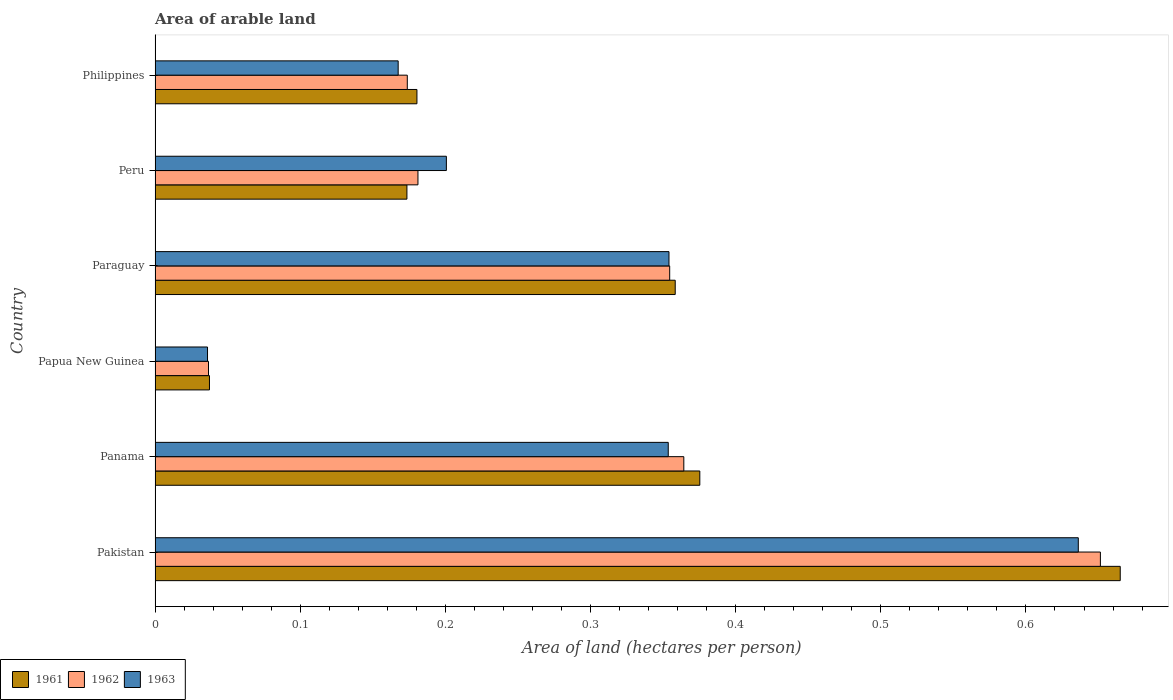How many different coloured bars are there?
Provide a succinct answer. 3. Are the number of bars per tick equal to the number of legend labels?
Your answer should be compact. Yes. Are the number of bars on each tick of the Y-axis equal?
Keep it short and to the point. Yes. How many bars are there on the 4th tick from the top?
Your answer should be compact. 3. What is the label of the 3rd group of bars from the top?
Offer a terse response. Paraguay. In how many cases, is the number of bars for a given country not equal to the number of legend labels?
Give a very brief answer. 0. What is the total arable land in 1962 in Papua New Guinea?
Offer a terse response. 0.04. Across all countries, what is the maximum total arable land in 1961?
Make the answer very short. 0.66. Across all countries, what is the minimum total arable land in 1963?
Offer a very short reply. 0.04. In which country was the total arable land in 1961 minimum?
Your answer should be very brief. Papua New Guinea. What is the total total arable land in 1962 in the graph?
Give a very brief answer. 1.76. What is the difference between the total arable land in 1962 in Peru and that in Philippines?
Provide a short and direct response. 0.01. What is the difference between the total arable land in 1961 in Pakistan and the total arable land in 1963 in Papua New Guinea?
Keep it short and to the point. 0.63. What is the average total arable land in 1962 per country?
Offer a very short reply. 0.29. What is the difference between the total arable land in 1961 and total arable land in 1963 in Pakistan?
Your response must be concise. 0.03. In how many countries, is the total arable land in 1962 greater than 0.52 hectares per person?
Give a very brief answer. 1. What is the ratio of the total arable land in 1961 in Paraguay to that in Philippines?
Give a very brief answer. 1.99. Is the difference between the total arable land in 1961 in Panama and Papua New Guinea greater than the difference between the total arable land in 1963 in Panama and Papua New Guinea?
Your answer should be compact. Yes. What is the difference between the highest and the second highest total arable land in 1961?
Your answer should be very brief. 0.29. What is the difference between the highest and the lowest total arable land in 1962?
Offer a very short reply. 0.61. In how many countries, is the total arable land in 1963 greater than the average total arable land in 1963 taken over all countries?
Provide a short and direct response. 3. Is the sum of the total arable land in 1963 in Peru and Philippines greater than the maximum total arable land in 1962 across all countries?
Provide a succinct answer. No. What does the 1st bar from the top in Philippines represents?
Ensure brevity in your answer.  1963. How many bars are there?
Offer a terse response. 18. Are all the bars in the graph horizontal?
Offer a very short reply. Yes. How many countries are there in the graph?
Provide a succinct answer. 6. What is the difference between two consecutive major ticks on the X-axis?
Give a very brief answer. 0.1. Does the graph contain grids?
Give a very brief answer. No. Where does the legend appear in the graph?
Provide a succinct answer. Bottom left. What is the title of the graph?
Offer a very short reply. Area of arable land. What is the label or title of the X-axis?
Keep it short and to the point. Area of land (hectares per person). What is the label or title of the Y-axis?
Provide a short and direct response. Country. What is the Area of land (hectares per person) of 1961 in Pakistan?
Provide a succinct answer. 0.66. What is the Area of land (hectares per person) in 1962 in Pakistan?
Provide a short and direct response. 0.65. What is the Area of land (hectares per person) of 1963 in Pakistan?
Your answer should be very brief. 0.64. What is the Area of land (hectares per person) in 1961 in Panama?
Offer a very short reply. 0.38. What is the Area of land (hectares per person) of 1962 in Panama?
Your response must be concise. 0.36. What is the Area of land (hectares per person) in 1963 in Panama?
Your answer should be compact. 0.35. What is the Area of land (hectares per person) of 1961 in Papua New Guinea?
Make the answer very short. 0.04. What is the Area of land (hectares per person) in 1962 in Papua New Guinea?
Your answer should be very brief. 0.04. What is the Area of land (hectares per person) in 1963 in Papua New Guinea?
Provide a succinct answer. 0.04. What is the Area of land (hectares per person) of 1961 in Paraguay?
Your answer should be very brief. 0.36. What is the Area of land (hectares per person) of 1962 in Paraguay?
Your response must be concise. 0.35. What is the Area of land (hectares per person) of 1963 in Paraguay?
Provide a succinct answer. 0.35. What is the Area of land (hectares per person) in 1961 in Peru?
Make the answer very short. 0.17. What is the Area of land (hectares per person) in 1962 in Peru?
Provide a succinct answer. 0.18. What is the Area of land (hectares per person) in 1963 in Peru?
Give a very brief answer. 0.2. What is the Area of land (hectares per person) in 1961 in Philippines?
Offer a terse response. 0.18. What is the Area of land (hectares per person) of 1962 in Philippines?
Give a very brief answer. 0.17. What is the Area of land (hectares per person) of 1963 in Philippines?
Keep it short and to the point. 0.17. Across all countries, what is the maximum Area of land (hectares per person) of 1961?
Make the answer very short. 0.66. Across all countries, what is the maximum Area of land (hectares per person) in 1962?
Give a very brief answer. 0.65. Across all countries, what is the maximum Area of land (hectares per person) in 1963?
Your answer should be very brief. 0.64. Across all countries, what is the minimum Area of land (hectares per person) in 1961?
Make the answer very short. 0.04. Across all countries, what is the minimum Area of land (hectares per person) in 1962?
Provide a short and direct response. 0.04. Across all countries, what is the minimum Area of land (hectares per person) in 1963?
Provide a short and direct response. 0.04. What is the total Area of land (hectares per person) of 1961 in the graph?
Keep it short and to the point. 1.79. What is the total Area of land (hectares per person) in 1962 in the graph?
Offer a terse response. 1.76. What is the total Area of land (hectares per person) in 1963 in the graph?
Offer a terse response. 1.75. What is the difference between the Area of land (hectares per person) of 1961 in Pakistan and that in Panama?
Give a very brief answer. 0.29. What is the difference between the Area of land (hectares per person) in 1962 in Pakistan and that in Panama?
Provide a succinct answer. 0.29. What is the difference between the Area of land (hectares per person) of 1963 in Pakistan and that in Panama?
Make the answer very short. 0.28. What is the difference between the Area of land (hectares per person) in 1961 in Pakistan and that in Papua New Guinea?
Keep it short and to the point. 0.63. What is the difference between the Area of land (hectares per person) of 1962 in Pakistan and that in Papua New Guinea?
Provide a short and direct response. 0.61. What is the difference between the Area of land (hectares per person) of 1963 in Pakistan and that in Papua New Guinea?
Your answer should be very brief. 0.6. What is the difference between the Area of land (hectares per person) of 1961 in Pakistan and that in Paraguay?
Keep it short and to the point. 0.31. What is the difference between the Area of land (hectares per person) in 1962 in Pakistan and that in Paraguay?
Offer a terse response. 0.3. What is the difference between the Area of land (hectares per person) in 1963 in Pakistan and that in Paraguay?
Ensure brevity in your answer.  0.28. What is the difference between the Area of land (hectares per person) of 1961 in Pakistan and that in Peru?
Make the answer very short. 0.49. What is the difference between the Area of land (hectares per person) in 1962 in Pakistan and that in Peru?
Your response must be concise. 0.47. What is the difference between the Area of land (hectares per person) of 1963 in Pakistan and that in Peru?
Your answer should be compact. 0.44. What is the difference between the Area of land (hectares per person) of 1961 in Pakistan and that in Philippines?
Keep it short and to the point. 0.48. What is the difference between the Area of land (hectares per person) of 1962 in Pakistan and that in Philippines?
Offer a very short reply. 0.48. What is the difference between the Area of land (hectares per person) in 1963 in Pakistan and that in Philippines?
Provide a succinct answer. 0.47. What is the difference between the Area of land (hectares per person) of 1961 in Panama and that in Papua New Guinea?
Offer a terse response. 0.34. What is the difference between the Area of land (hectares per person) in 1962 in Panama and that in Papua New Guinea?
Keep it short and to the point. 0.33. What is the difference between the Area of land (hectares per person) of 1963 in Panama and that in Papua New Guinea?
Offer a very short reply. 0.32. What is the difference between the Area of land (hectares per person) in 1961 in Panama and that in Paraguay?
Offer a very short reply. 0.02. What is the difference between the Area of land (hectares per person) of 1962 in Panama and that in Paraguay?
Offer a terse response. 0.01. What is the difference between the Area of land (hectares per person) in 1963 in Panama and that in Paraguay?
Make the answer very short. -0. What is the difference between the Area of land (hectares per person) of 1961 in Panama and that in Peru?
Your response must be concise. 0.2. What is the difference between the Area of land (hectares per person) of 1962 in Panama and that in Peru?
Make the answer very short. 0.18. What is the difference between the Area of land (hectares per person) of 1963 in Panama and that in Peru?
Provide a short and direct response. 0.15. What is the difference between the Area of land (hectares per person) of 1961 in Panama and that in Philippines?
Offer a terse response. 0.19. What is the difference between the Area of land (hectares per person) in 1962 in Panama and that in Philippines?
Offer a very short reply. 0.19. What is the difference between the Area of land (hectares per person) of 1963 in Panama and that in Philippines?
Your answer should be very brief. 0.19. What is the difference between the Area of land (hectares per person) of 1961 in Papua New Guinea and that in Paraguay?
Your response must be concise. -0.32. What is the difference between the Area of land (hectares per person) in 1962 in Papua New Guinea and that in Paraguay?
Give a very brief answer. -0.32. What is the difference between the Area of land (hectares per person) of 1963 in Papua New Guinea and that in Paraguay?
Your answer should be compact. -0.32. What is the difference between the Area of land (hectares per person) in 1961 in Papua New Guinea and that in Peru?
Your answer should be very brief. -0.14. What is the difference between the Area of land (hectares per person) in 1962 in Papua New Guinea and that in Peru?
Your answer should be compact. -0.14. What is the difference between the Area of land (hectares per person) in 1963 in Papua New Guinea and that in Peru?
Give a very brief answer. -0.16. What is the difference between the Area of land (hectares per person) of 1961 in Papua New Guinea and that in Philippines?
Provide a succinct answer. -0.14. What is the difference between the Area of land (hectares per person) in 1962 in Papua New Guinea and that in Philippines?
Your answer should be very brief. -0.14. What is the difference between the Area of land (hectares per person) in 1963 in Papua New Guinea and that in Philippines?
Ensure brevity in your answer.  -0.13. What is the difference between the Area of land (hectares per person) of 1961 in Paraguay and that in Peru?
Your response must be concise. 0.18. What is the difference between the Area of land (hectares per person) in 1962 in Paraguay and that in Peru?
Keep it short and to the point. 0.17. What is the difference between the Area of land (hectares per person) in 1963 in Paraguay and that in Peru?
Offer a terse response. 0.15. What is the difference between the Area of land (hectares per person) in 1961 in Paraguay and that in Philippines?
Provide a succinct answer. 0.18. What is the difference between the Area of land (hectares per person) of 1962 in Paraguay and that in Philippines?
Provide a succinct answer. 0.18. What is the difference between the Area of land (hectares per person) in 1963 in Paraguay and that in Philippines?
Keep it short and to the point. 0.19. What is the difference between the Area of land (hectares per person) in 1961 in Peru and that in Philippines?
Your answer should be compact. -0.01. What is the difference between the Area of land (hectares per person) of 1962 in Peru and that in Philippines?
Your answer should be compact. 0.01. What is the difference between the Area of land (hectares per person) of 1963 in Peru and that in Philippines?
Your answer should be very brief. 0.03. What is the difference between the Area of land (hectares per person) in 1961 in Pakistan and the Area of land (hectares per person) in 1962 in Panama?
Your answer should be compact. 0.3. What is the difference between the Area of land (hectares per person) of 1961 in Pakistan and the Area of land (hectares per person) of 1963 in Panama?
Your response must be concise. 0.31. What is the difference between the Area of land (hectares per person) of 1962 in Pakistan and the Area of land (hectares per person) of 1963 in Panama?
Keep it short and to the point. 0.3. What is the difference between the Area of land (hectares per person) in 1961 in Pakistan and the Area of land (hectares per person) in 1962 in Papua New Guinea?
Ensure brevity in your answer.  0.63. What is the difference between the Area of land (hectares per person) in 1961 in Pakistan and the Area of land (hectares per person) in 1963 in Papua New Guinea?
Give a very brief answer. 0.63. What is the difference between the Area of land (hectares per person) in 1962 in Pakistan and the Area of land (hectares per person) in 1963 in Papua New Guinea?
Give a very brief answer. 0.62. What is the difference between the Area of land (hectares per person) in 1961 in Pakistan and the Area of land (hectares per person) in 1962 in Paraguay?
Your answer should be compact. 0.31. What is the difference between the Area of land (hectares per person) in 1961 in Pakistan and the Area of land (hectares per person) in 1963 in Paraguay?
Your answer should be compact. 0.31. What is the difference between the Area of land (hectares per person) in 1962 in Pakistan and the Area of land (hectares per person) in 1963 in Paraguay?
Make the answer very short. 0.3. What is the difference between the Area of land (hectares per person) of 1961 in Pakistan and the Area of land (hectares per person) of 1962 in Peru?
Give a very brief answer. 0.48. What is the difference between the Area of land (hectares per person) in 1961 in Pakistan and the Area of land (hectares per person) in 1963 in Peru?
Offer a terse response. 0.46. What is the difference between the Area of land (hectares per person) in 1962 in Pakistan and the Area of land (hectares per person) in 1963 in Peru?
Give a very brief answer. 0.45. What is the difference between the Area of land (hectares per person) of 1961 in Pakistan and the Area of land (hectares per person) of 1962 in Philippines?
Provide a short and direct response. 0.49. What is the difference between the Area of land (hectares per person) of 1961 in Pakistan and the Area of land (hectares per person) of 1963 in Philippines?
Provide a succinct answer. 0.5. What is the difference between the Area of land (hectares per person) of 1962 in Pakistan and the Area of land (hectares per person) of 1963 in Philippines?
Give a very brief answer. 0.48. What is the difference between the Area of land (hectares per person) of 1961 in Panama and the Area of land (hectares per person) of 1962 in Papua New Guinea?
Provide a short and direct response. 0.34. What is the difference between the Area of land (hectares per person) in 1961 in Panama and the Area of land (hectares per person) in 1963 in Papua New Guinea?
Your answer should be very brief. 0.34. What is the difference between the Area of land (hectares per person) of 1962 in Panama and the Area of land (hectares per person) of 1963 in Papua New Guinea?
Provide a short and direct response. 0.33. What is the difference between the Area of land (hectares per person) of 1961 in Panama and the Area of land (hectares per person) of 1962 in Paraguay?
Offer a terse response. 0.02. What is the difference between the Area of land (hectares per person) of 1961 in Panama and the Area of land (hectares per person) of 1963 in Paraguay?
Your response must be concise. 0.02. What is the difference between the Area of land (hectares per person) of 1962 in Panama and the Area of land (hectares per person) of 1963 in Paraguay?
Your answer should be compact. 0.01. What is the difference between the Area of land (hectares per person) in 1961 in Panama and the Area of land (hectares per person) in 1962 in Peru?
Offer a terse response. 0.19. What is the difference between the Area of land (hectares per person) of 1961 in Panama and the Area of land (hectares per person) of 1963 in Peru?
Offer a terse response. 0.17. What is the difference between the Area of land (hectares per person) of 1962 in Panama and the Area of land (hectares per person) of 1963 in Peru?
Your answer should be compact. 0.16. What is the difference between the Area of land (hectares per person) of 1961 in Panama and the Area of land (hectares per person) of 1962 in Philippines?
Provide a succinct answer. 0.2. What is the difference between the Area of land (hectares per person) in 1961 in Panama and the Area of land (hectares per person) in 1963 in Philippines?
Provide a succinct answer. 0.21. What is the difference between the Area of land (hectares per person) in 1962 in Panama and the Area of land (hectares per person) in 1963 in Philippines?
Give a very brief answer. 0.2. What is the difference between the Area of land (hectares per person) in 1961 in Papua New Guinea and the Area of land (hectares per person) in 1962 in Paraguay?
Offer a very short reply. -0.32. What is the difference between the Area of land (hectares per person) of 1961 in Papua New Guinea and the Area of land (hectares per person) of 1963 in Paraguay?
Provide a short and direct response. -0.32. What is the difference between the Area of land (hectares per person) in 1962 in Papua New Guinea and the Area of land (hectares per person) in 1963 in Paraguay?
Make the answer very short. -0.32. What is the difference between the Area of land (hectares per person) of 1961 in Papua New Guinea and the Area of land (hectares per person) of 1962 in Peru?
Your answer should be very brief. -0.14. What is the difference between the Area of land (hectares per person) in 1961 in Papua New Guinea and the Area of land (hectares per person) in 1963 in Peru?
Provide a succinct answer. -0.16. What is the difference between the Area of land (hectares per person) in 1962 in Papua New Guinea and the Area of land (hectares per person) in 1963 in Peru?
Your answer should be compact. -0.16. What is the difference between the Area of land (hectares per person) in 1961 in Papua New Guinea and the Area of land (hectares per person) in 1962 in Philippines?
Ensure brevity in your answer.  -0.14. What is the difference between the Area of land (hectares per person) in 1961 in Papua New Guinea and the Area of land (hectares per person) in 1963 in Philippines?
Your answer should be very brief. -0.13. What is the difference between the Area of land (hectares per person) in 1962 in Papua New Guinea and the Area of land (hectares per person) in 1963 in Philippines?
Your answer should be very brief. -0.13. What is the difference between the Area of land (hectares per person) in 1961 in Paraguay and the Area of land (hectares per person) in 1962 in Peru?
Ensure brevity in your answer.  0.18. What is the difference between the Area of land (hectares per person) in 1961 in Paraguay and the Area of land (hectares per person) in 1963 in Peru?
Provide a succinct answer. 0.16. What is the difference between the Area of land (hectares per person) in 1962 in Paraguay and the Area of land (hectares per person) in 1963 in Peru?
Provide a short and direct response. 0.15. What is the difference between the Area of land (hectares per person) of 1961 in Paraguay and the Area of land (hectares per person) of 1962 in Philippines?
Provide a short and direct response. 0.18. What is the difference between the Area of land (hectares per person) of 1961 in Paraguay and the Area of land (hectares per person) of 1963 in Philippines?
Keep it short and to the point. 0.19. What is the difference between the Area of land (hectares per person) in 1962 in Paraguay and the Area of land (hectares per person) in 1963 in Philippines?
Keep it short and to the point. 0.19. What is the difference between the Area of land (hectares per person) in 1961 in Peru and the Area of land (hectares per person) in 1962 in Philippines?
Provide a short and direct response. -0. What is the difference between the Area of land (hectares per person) in 1961 in Peru and the Area of land (hectares per person) in 1963 in Philippines?
Make the answer very short. 0.01. What is the difference between the Area of land (hectares per person) in 1962 in Peru and the Area of land (hectares per person) in 1963 in Philippines?
Offer a terse response. 0.01. What is the average Area of land (hectares per person) of 1961 per country?
Your response must be concise. 0.3. What is the average Area of land (hectares per person) of 1962 per country?
Provide a short and direct response. 0.29. What is the average Area of land (hectares per person) in 1963 per country?
Offer a terse response. 0.29. What is the difference between the Area of land (hectares per person) in 1961 and Area of land (hectares per person) in 1962 in Pakistan?
Give a very brief answer. 0.01. What is the difference between the Area of land (hectares per person) of 1961 and Area of land (hectares per person) of 1963 in Pakistan?
Your answer should be very brief. 0.03. What is the difference between the Area of land (hectares per person) in 1962 and Area of land (hectares per person) in 1963 in Pakistan?
Your answer should be very brief. 0.02. What is the difference between the Area of land (hectares per person) of 1961 and Area of land (hectares per person) of 1962 in Panama?
Provide a short and direct response. 0.01. What is the difference between the Area of land (hectares per person) of 1961 and Area of land (hectares per person) of 1963 in Panama?
Give a very brief answer. 0.02. What is the difference between the Area of land (hectares per person) of 1962 and Area of land (hectares per person) of 1963 in Panama?
Provide a short and direct response. 0.01. What is the difference between the Area of land (hectares per person) of 1961 and Area of land (hectares per person) of 1962 in Papua New Guinea?
Keep it short and to the point. 0. What is the difference between the Area of land (hectares per person) in 1961 and Area of land (hectares per person) in 1963 in Papua New Guinea?
Keep it short and to the point. 0. What is the difference between the Area of land (hectares per person) in 1962 and Area of land (hectares per person) in 1963 in Papua New Guinea?
Keep it short and to the point. 0. What is the difference between the Area of land (hectares per person) of 1961 and Area of land (hectares per person) of 1962 in Paraguay?
Make the answer very short. 0. What is the difference between the Area of land (hectares per person) in 1961 and Area of land (hectares per person) in 1963 in Paraguay?
Offer a very short reply. 0. What is the difference between the Area of land (hectares per person) of 1962 and Area of land (hectares per person) of 1963 in Paraguay?
Your answer should be compact. 0. What is the difference between the Area of land (hectares per person) of 1961 and Area of land (hectares per person) of 1962 in Peru?
Provide a short and direct response. -0.01. What is the difference between the Area of land (hectares per person) of 1961 and Area of land (hectares per person) of 1963 in Peru?
Provide a succinct answer. -0.03. What is the difference between the Area of land (hectares per person) in 1962 and Area of land (hectares per person) in 1963 in Peru?
Provide a short and direct response. -0.02. What is the difference between the Area of land (hectares per person) of 1961 and Area of land (hectares per person) of 1962 in Philippines?
Your response must be concise. 0.01. What is the difference between the Area of land (hectares per person) in 1961 and Area of land (hectares per person) in 1963 in Philippines?
Keep it short and to the point. 0.01. What is the difference between the Area of land (hectares per person) in 1962 and Area of land (hectares per person) in 1963 in Philippines?
Ensure brevity in your answer.  0.01. What is the ratio of the Area of land (hectares per person) of 1961 in Pakistan to that in Panama?
Offer a very short reply. 1.77. What is the ratio of the Area of land (hectares per person) in 1962 in Pakistan to that in Panama?
Make the answer very short. 1.79. What is the ratio of the Area of land (hectares per person) in 1963 in Pakistan to that in Panama?
Provide a succinct answer. 1.8. What is the ratio of the Area of land (hectares per person) of 1961 in Pakistan to that in Papua New Guinea?
Offer a terse response. 17.74. What is the ratio of the Area of land (hectares per person) in 1962 in Pakistan to that in Papua New Guinea?
Your answer should be very brief. 17.69. What is the ratio of the Area of land (hectares per person) in 1963 in Pakistan to that in Papua New Guinea?
Your answer should be compact. 17.6. What is the ratio of the Area of land (hectares per person) in 1961 in Pakistan to that in Paraguay?
Your response must be concise. 1.86. What is the ratio of the Area of land (hectares per person) in 1962 in Pakistan to that in Paraguay?
Offer a very short reply. 1.84. What is the ratio of the Area of land (hectares per person) of 1963 in Pakistan to that in Paraguay?
Provide a short and direct response. 1.8. What is the ratio of the Area of land (hectares per person) in 1961 in Pakistan to that in Peru?
Ensure brevity in your answer.  3.83. What is the ratio of the Area of land (hectares per person) of 1962 in Pakistan to that in Peru?
Offer a very short reply. 3.6. What is the ratio of the Area of land (hectares per person) of 1963 in Pakistan to that in Peru?
Give a very brief answer. 3.17. What is the ratio of the Area of land (hectares per person) in 1961 in Pakistan to that in Philippines?
Offer a very short reply. 3.69. What is the ratio of the Area of land (hectares per person) of 1962 in Pakistan to that in Philippines?
Your answer should be very brief. 3.75. What is the ratio of the Area of land (hectares per person) of 1963 in Pakistan to that in Philippines?
Ensure brevity in your answer.  3.8. What is the ratio of the Area of land (hectares per person) of 1961 in Panama to that in Papua New Guinea?
Your response must be concise. 10.01. What is the ratio of the Area of land (hectares per person) of 1962 in Panama to that in Papua New Guinea?
Make the answer very short. 9.89. What is the ratio of the Area of land (hectares per person) in 1963 in Panama to that in Papua New Guinea?
Your answer should be very brief. 9.78. What is the ratio of the Area of land (hectares per person) in 1961 in Panama to that in Paraguay?
Give a very brief answer. 1.05. What is the ratio of the Area of land (hectares per person) of 1962 in Panama to that in Paraguay?
Offer a terse response. 1.03. What is the ratio of the Area of land (hectares per person) of 1963 in Panama to that in Paraguay?
Provide a succinct answer. 1. What is the ratio of the Area of land (hectares per person) of 1961 in Panama to that in Peru?
Your response must be concise. 2.16. What is the ratio of the Area of land (hectares per person) of 1962 in Panama to that in Peru?
Your answer should be compact. 2.01. What is the ratio of the Area of land (hectares per person) of 1963 in Panama to that in Peru?
Your answer should be very brief. 1.76. What is the ratio of the Area of land (hectares per person) in 1961 in Panama to that in Philippines?
Keep it short and to the point. 2.08. What is the ratio of the Area of land (hectares per person) in 1962 in Panama to that in Philippines?
Give a very brief answer. 2.1. What is the ratio of the Area of land (hectares per person) of 1963 in Panama to that in Philippines?
Keep it short and to the point. 2.11. What is the ratio of the Area of land (hectares per person) in 1961 in Papua New Guinea to that in Paraguay?
Your answer should be very brief. 0.1. What is the ratio of the Area of land (hectares per person) of 1962 in Papua New Guinea to that in Paraguay?
Ensure brevity in your answer.  0.1. What is the ratio of the Area of land (hectares per person) of 1963 in Papua New Guinea to that in Paraguay?
Ensure brevity in your answer.  0.1. What is the ratio of the Area of land (hectares per person) of 1961 in Papua New Guinea to that in Peru?
Provide a succinct answer. 0.22. What is the ratio of the Area of land (hectares per person) of 1962 in Papua New Guinea to that in Peru?
Offer a terse response. 0.2. What is the ratio of the Area of land (hectares per person) of 1963 in Papua New Guinea to that in Peru?
Offer a very short reply. 0.18. What is the ratio of the Area of land (hectares per person) in 1961 in Papua New Guinea to that in Philippines?
Your response must be concise. 0.21. What is the ratio of the Area of land (hectares per person) in 1962 in Papua New Guinea to that in Philippines?
Provide a succinct answer. 0.21. What is the ratio of the Area of land (hectares per person) in 1963 in Papua New Guinea to that in Philippines?
Your answer should be very brief. 0.22. What is the ratio of the Area of land (hectares per person) of 1961 in Paraguay to that in Peru?
Give a very brief answer. 2.07. What is the ratio of the Area of land (hectares per person) in 1962 in Paraguay to that in Peru?
Offer a terse response. 1.96. What is the ratio of the Area of land (hectares per person) of 1963 in Paraguay to that in Peru?
Ensure brevity in your answer.  1.76. What is the ratio of the Area of land (hectares per person) in 1961 in Paraguay to that in Philippines?
Offer a very short reply. 1.99. What is the ratio of the Area of land (hectares per person) of 1962 in Paraguay to that in Philippines?
Offer a terse response. 2.04. What is the ratio of the Area of land (hectares per person) of 1963 in Paraguay to that in Philippines?
Make the answer very short. 2.11. What is the ratio of the Area of land (hectares per person) of 1961 in Peru to that in Philippines?
Make the answer very short. 0.96. What is the ratio of the Area of land (hectares per person) in 1962 in Peru to that in Philippines?
Offer a terse response. 1.04. What is the ratio of the Area of land (hectares per person) of 1963 in Peru to that in Philippines?
Your answer should be compact. 1.2. What is the difference between the highest and the second highest Area of land (hectares per person) in 1961?
Provide a short and direct response. 0.29. What is the difference between the highest and the second highest Area of land (hectares per person) in 1962?
Keep it short and to the point. 0.29. What is the difference between the highest and the second highest Area of land (hectares per person) of 1963?
Give a very brief answer. 0.28. What is the difference between the highest and the lowest Area of land (hectares per person) in 1961?
Give a very brief answer. 0.63. What is the difference between the highest and the lowest Area of land (hectares per person) of 1962?
Provide a succinct answer. 0.61. What is the difference between the highest and the lowest Area of land (hectares per person) of 1963?
Provide a short and direct response. 0.6. 